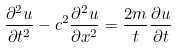Convert formula to latex. <formula><loc_0><loc_0><loc_500><loc_500>\frac { \partial ^ { 2 } u } { \partial t ^ { 2 } } - c ^ { 2 } \frac { \partial ^ { 2 } u } { \partial x ^ { 2 } } = \frac { 2 m } { t } \frac { \partial u } { \partial t }</formula> 